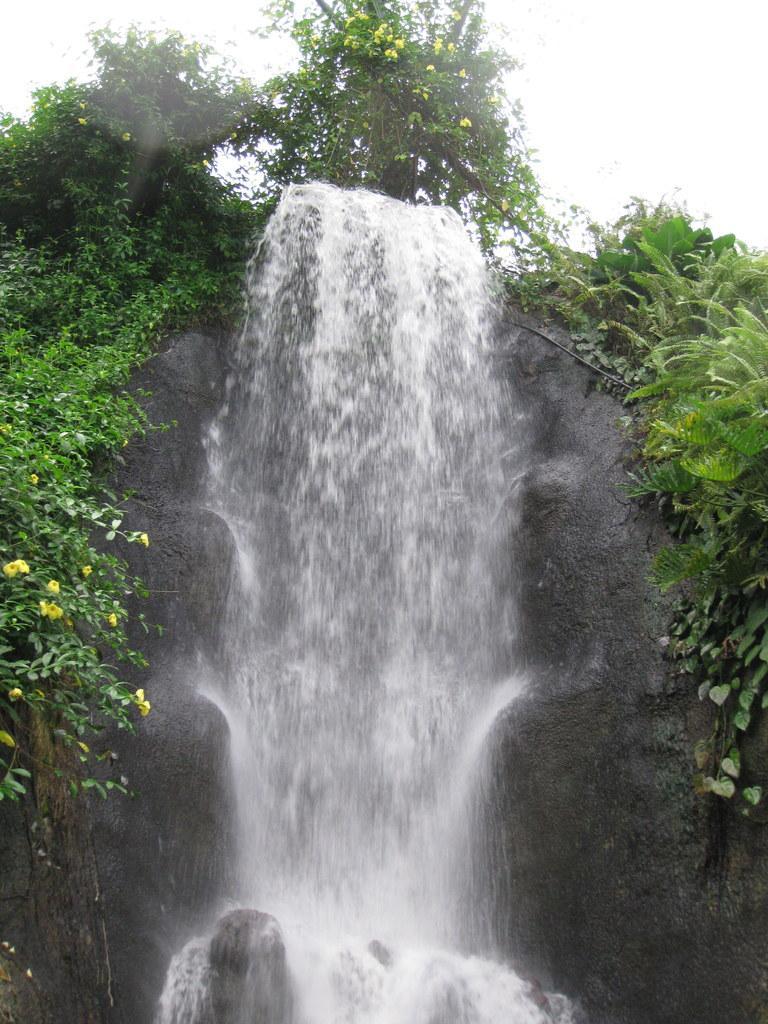Can you describe this image briefly? In this picture I can see the plants and grass. At the top there is a tree. In the top right I can see the sky. 